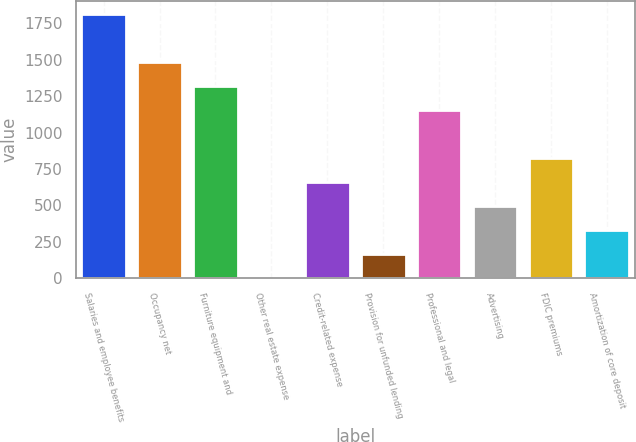Convert chart. <chart><loc_0><loc_0><loc_500><loc_500><bar_chart><fcel>Salaries and employee benefits<fcel>Occupancy net<fcel>Furniture equipment and<fcel>Other real estate expense<fcel>Credit-related expense<fcel>Provision for unfunded lending<fcel>Professional and legal<fcel>Advertising<fcel>FDIC premiums<fcel>Amortization of core deposit<nl><fcel>1814.22<fcel>1484.58<fcel>1319.76<fcel>1.2<fcel>660.48<fcel>166.02<fcel>1154.94<fcel>495.66<fcel>825.3<fcel>330.84<nl></chart> 